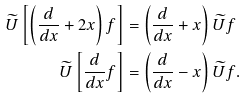<formula> <loc_0><loc_0><loc_500><loc_500>\widetilde { U } \left [ \left ( \frac { d } { d x } + 2 x \right ) f \right ] & = \left ( \frac { d } { d x } + x \right ) \widetilde { U } f \\ \widetilde { U } \left [ \frac { d } { d x } f \right ] & = \left ( \frac { d } { d x } - x \right ) \widetilde { U } f .</formula> 